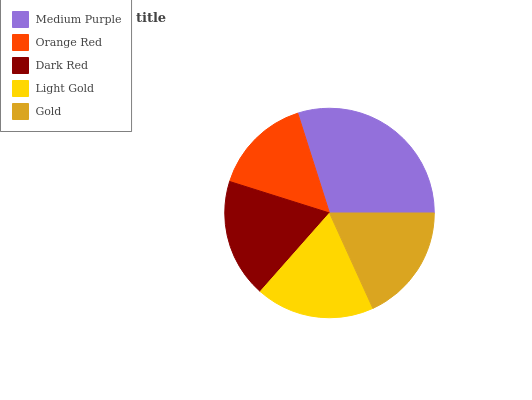Is Orange Red the minimum?
Answer yes or no. Yes. Is Medium Purple the maximum?
Answer yes or no. Yes. Is Dark Red the minimum?
Answer yes or no. No. Is Dark Red the maximum?
Answer yes or no. No. Is Dark Red greater than Orange Red?
Answer yes or no. Yes. Is Orange Red less than Dark Red?
Answer yes or no. Yes. Is Orange Red greater than Dark Red?
Answer yes or no. No. Is Dark Red less than Orange Red?
Answer yes or no. No. Is Light Gold the high median?
Answer yes or no. Yes. Is Light Gold the low median?
Answer yes or no. Yes. Is Orange Red the high median?
Answer yes or no. No. Is Orange Red the low median?
Answer yes or no. No. 